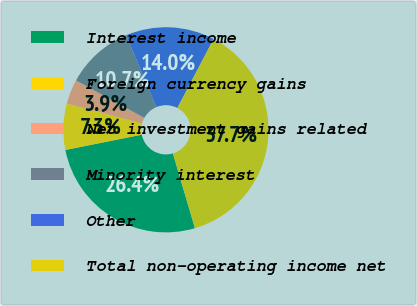<chart> <loc_0><loc_0><loc_500><loc_500><pie_chart><fcel>Interest income<fcel>Foreign currency gains<fcel>Net investment gains related<fcel>Minority interest<fcel>Other<fcel>Total non-operating income net<nl><fcel>26.41%<fcel>7.27%<fcel>3.88%<fcel>10.66%<fcel>14.04%<fcel>37.74%<nl></chart> 